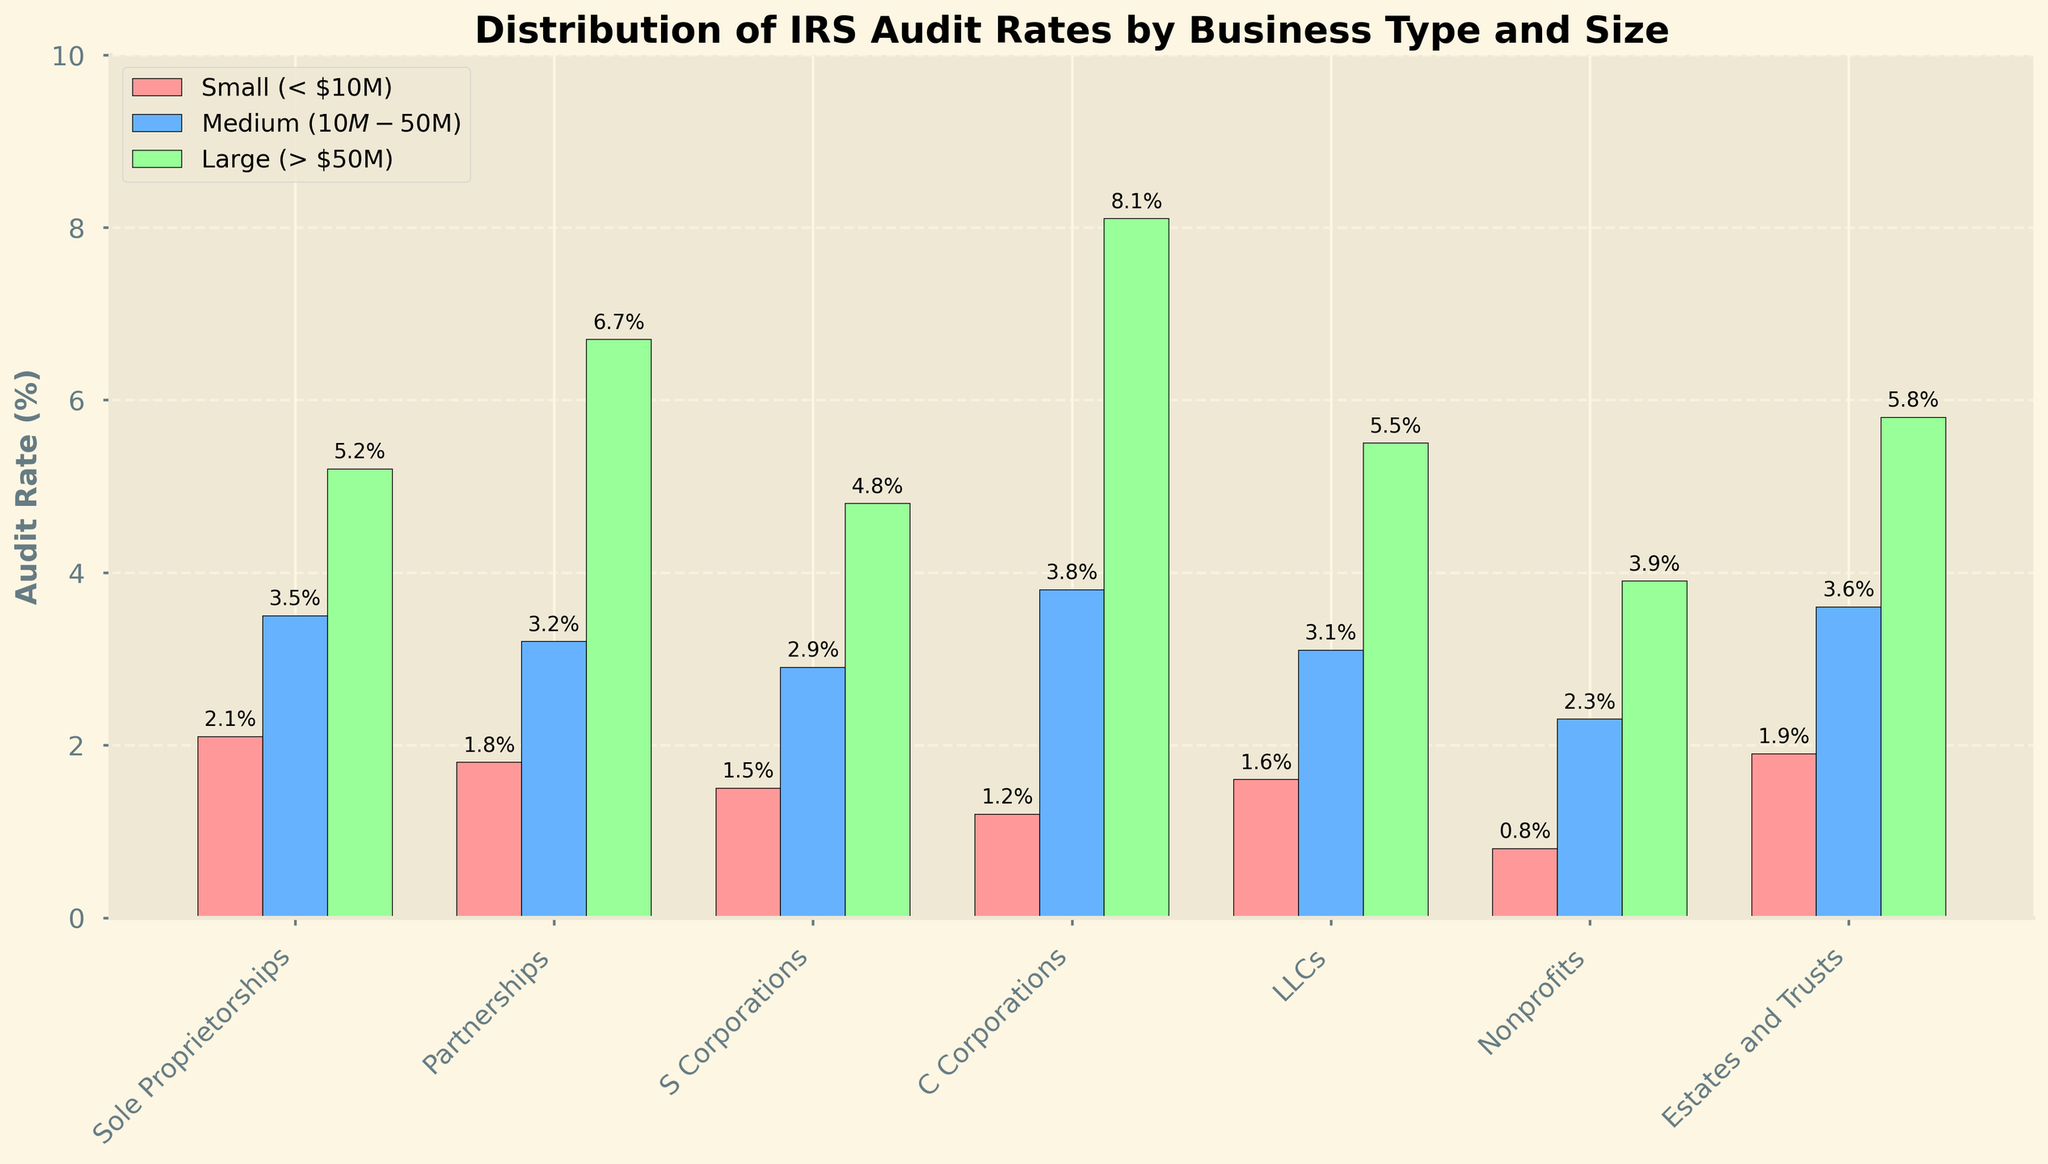Which business type has the highest audit rate for Large (> $50M) businesses? To find the business type with the highest audit rate for large businesses, look at the third column of bars in each group. The tallest bar, representing the highest percentage, is for C Corporations.
Answer: C Corporations Which business type has the lowest audit rate for Small (< $10M) businesses? To determine the business type with the lowest audit rate for small businesses, examine the first column of bars in each group. The shortest bar, indicating the lowest percentage, is for Nonprofits.
Answer: Nonprofits What is the difference in audit rate between Small (< $10M) and Medium ($10M-$50M) S Corporations? To find the difference, subtract the audit rate of Small S Corporations from that of Medium S Corporations. From the figure, the rates are 2.9% (Medium) and 1.5% (Small), so 2.9% - 1.5% = 1.4%.
Answer: 1.4% Which business type has the most consistent audit rate across all sizes? To find the business type with the most consistent audit rates, look at the visual similarity in bar heights across all three size categories for each business type. Sole Proprietorships have bars that are relatively close in height across the sizes.
Answer: Sole Proprietorships For which business type is the audit rate for Large (> $50M) businesses more than double the rate for Small (< $10M) businesses? Identify instances where the large business audit rate is more than double the small business rate. For C Corporations, the rates are 8.1% (Large) and 1.2% (Small). 8.1% is more than double 1.2%.
Answer: C Corporations What is the average audit rate for Medium ($10M-$50M) businesses? Calculate the average by summing the audit rates for Medium businesses and dividing by the number of business types. The rates are 3.5%, 3.2%, 2.9%, 3.8%, 3.1%, 2.3%, and 3.6%. Summing these gives 22.4%, and dividing by 7 types gives an average of 22.4% / 7 ≈ 3.2%.
Answer: 3.2% How much higher is the audit rate for Large (> $50M) LLCs compared to Small (< $10M) LLCs? Subtract the audit rate of Small LLCs from that of Large LLCs. The rates are 5.5% (Large) and 1.6% (Small), so 5.5% - 1.6% = 3.9%.
Answer: 3.9% Which size category has the highest overall audit rates across all business types? To find this, compare the sum of audit rates for each size category. Large businesses generally have the highest rates across each business type.
Answer: Large (> $50M) In which size category do Estates and Trusts have a higher audit rate than S Corporations? Compare the audit rates for Estates and Trusts with those for S Corporations across all size categories. Estates and Trusts have a higher rate in the Small (< $10M) category (1.9% vs. 1.5%).
Answer: Small (< $10M) What is the combined audit rate for Small (< $10M) Partnerships and Large (> $50M) Nonprofits? Add the audit rates of Small Partnerships (1.8%) and Large Nonprofits (3.9%). The combined rate is 1.8% + 3.9% = 5.7%.
Answer: 5.7% 